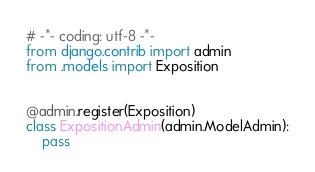Convert code to text. <code><loc_0><loc_0><loc_500><loc_500><_Python_># -*- coding: utf-8 -*-
from django.contrib import admin
from .models import Exposition


@admin.register(Exposition)
class ExpositionAdmin(admin.ModelAdmin):
    pass
</code> 